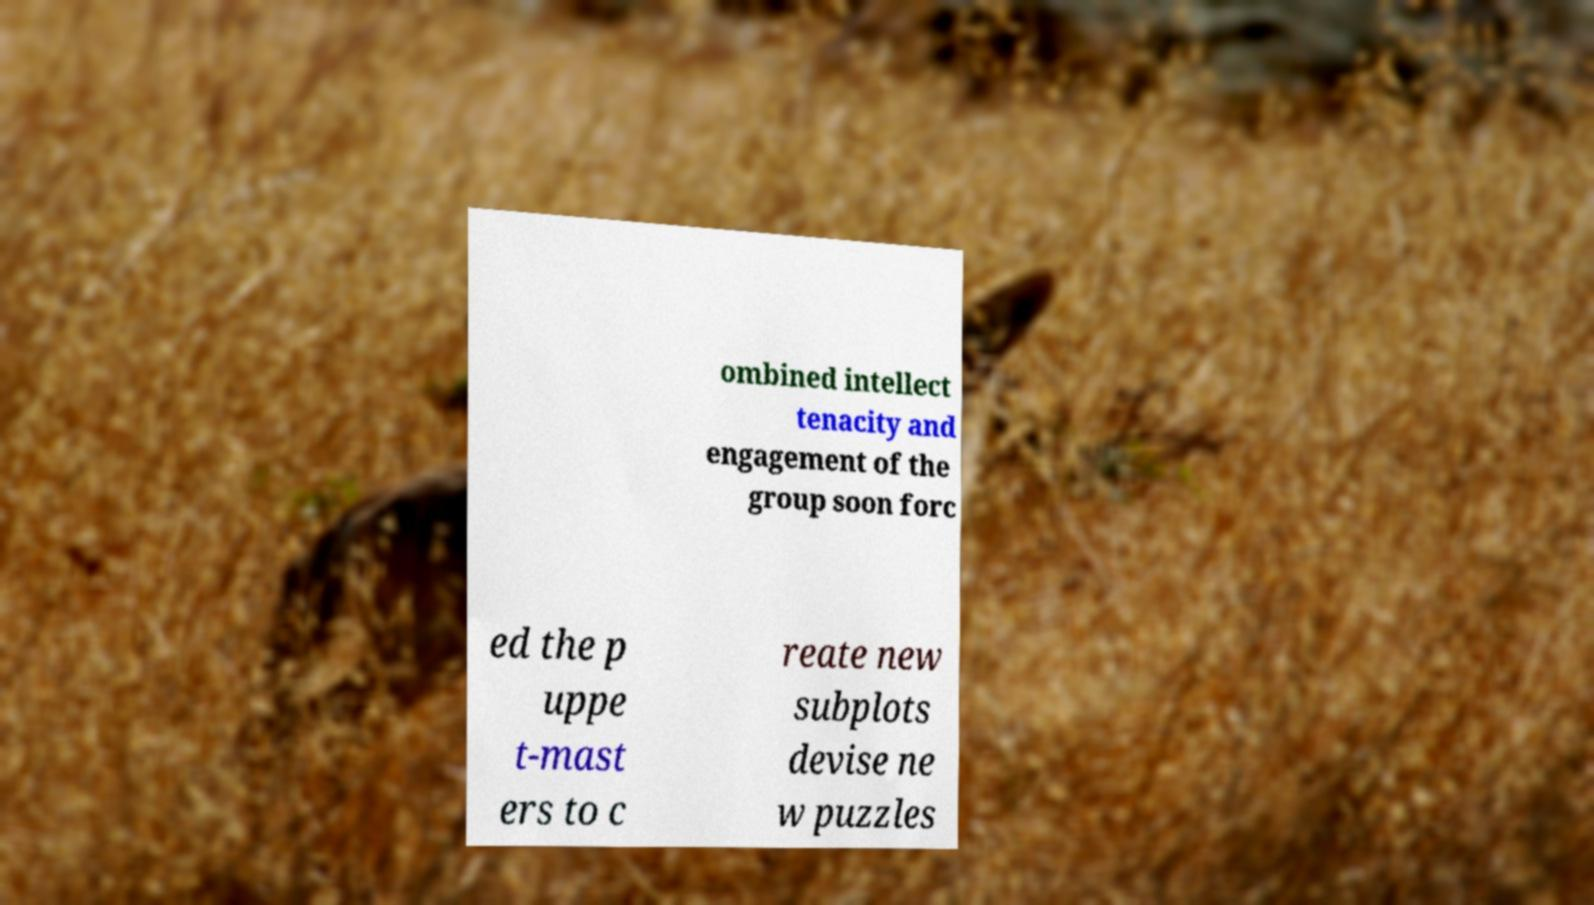Could you extract and type out the text from this image? ombined intellect tenacity and engagement of the group soon forc ed the p uppe t-mast ers to c reate new subplots devise ne w puzzles 